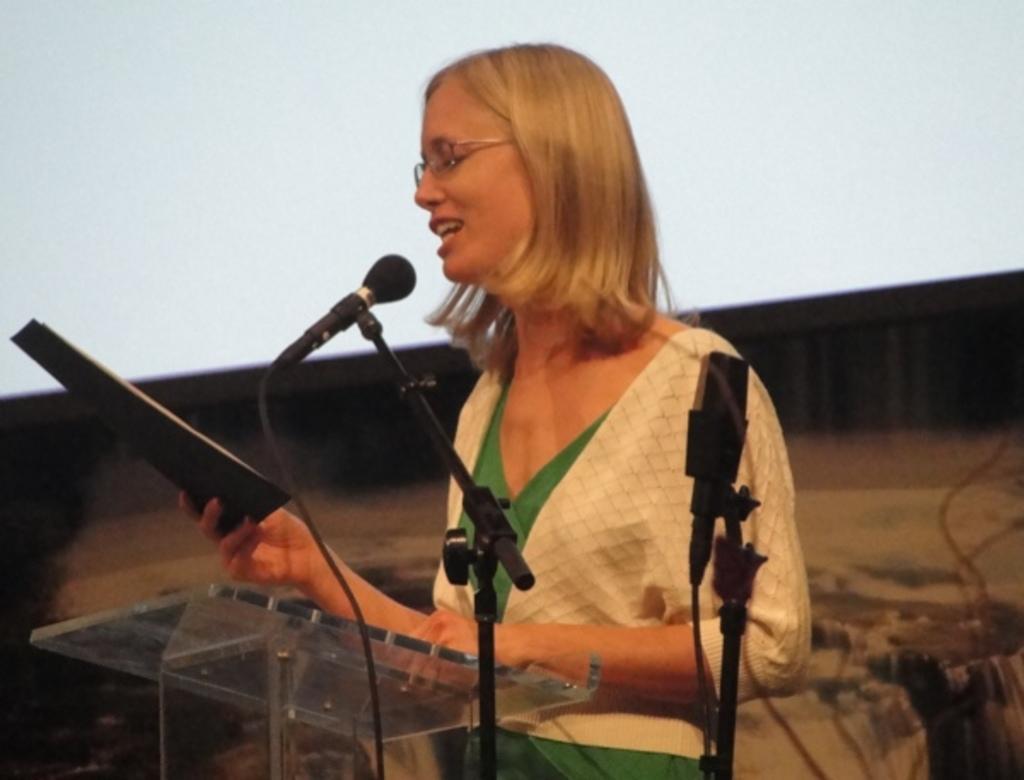Can you describe this image briefly? In this picture I can see a woman speaking into microphone and also she is holding a book. 